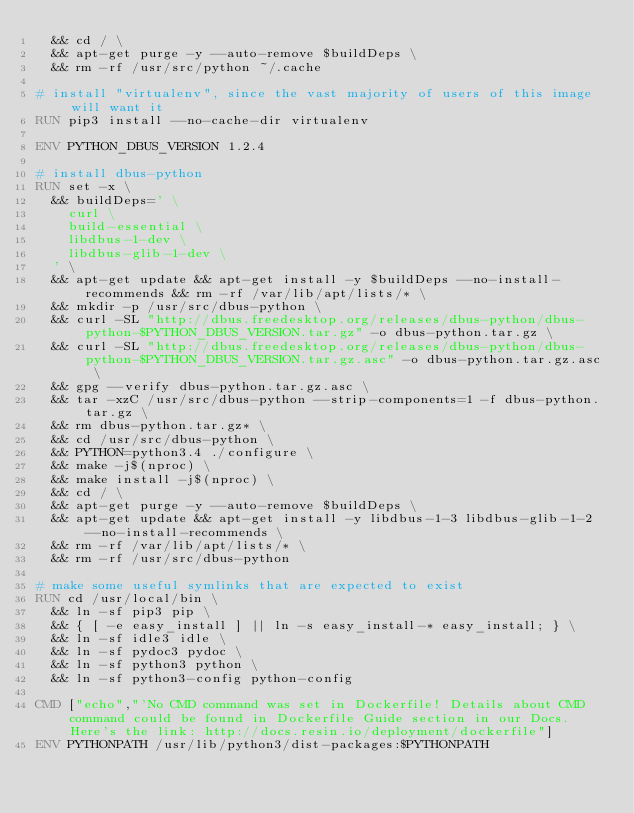Convert code to text. <code><loc_0><loc_0><loc_500><loc_500><_Dockerfile_>	&& cd / \
	&& apt-get purge -y --auto-remove $buildDeps \
	&& rm -rf /usr/src/python ~/.cache

# install "virtualenv", since the vast majority of users of this image will want it
RUN pip3 install --no-cache-dir virtualenv

ENV PYTHON_DBUS_VERSION 1.2.4

# install dbus-python
RUN set -x \
	&& buildDeps=' \
		curl \
		build-essential \
		libdbus-1-dev \
		libdbus-glib-1-dev \
	' \
	&& apt-get update && apt-get install -y $buildDeps --no-install-recommends && rm -rf /var/lib/apt/lists/* \
	&& mkdir -p /usr/src/dbus-python \
	&& curl -SL "http://dbus.freedesktop.org/releases/dbus-python/dbus-python-$PYTHON_DBUS_VERSION.tar.gz" -o dbus-python.tar.gz \
	&& curl -SL "http://dbus.freedesktop.org/releases/dbus-python/dbus-python-$PYTHON_DBUS_VERSION.tar.gz.asc" -o dbus-python.tar.gz.asc \
	&& gpg --verify dbus-python.tar.gz.asc \
	&& tar -xzC /usr/src/dbus-python --strip-components=1 -f dbus-python.tar.gz \
	&& rm dbus-python.tar.gz* \
	&& cd /usr/src/dbus-python \
	&& PYTHON=python3.4 ./configure \
	&& make -j$(nproc) \
	&& make install -j$(nproc) \
	&& cd / \
	&& apt-get purge -y --auto-remove $buildDeps \
	&& apt-get update && apt-get install -y libdbus-1-3 libdbus-glib-1-2 --no-install-recommends \
	&& rm -rf /var/lib/apt/lists/* \
	&& rm -rf /usr/src/dbus-python

# make some useful symlinks that are expected to exist
RUN cd /usr/local/bin \
	&& ln -sf pip3 pip \
	&& { [ -e easy_install ] || ln -s easy_install-* easy_install; } \
	&& ln -sf idle3 idle \
	&& ln -sf pydoc3 pydoc \
	&& ln -sf python3 python \
	&& ln -sf python3-config python-config

CMD ["echo","'No CMD command was set in Dockerfile! Details about CMD command could be found in Dockerfile Guide section in our Docs. Here's the link: http://docs.resin.io/deployment/dockerfile"]
ENV PYTHONPATH /usr/lib/python3/dist-packages:$PYTHONPATH
</code> 